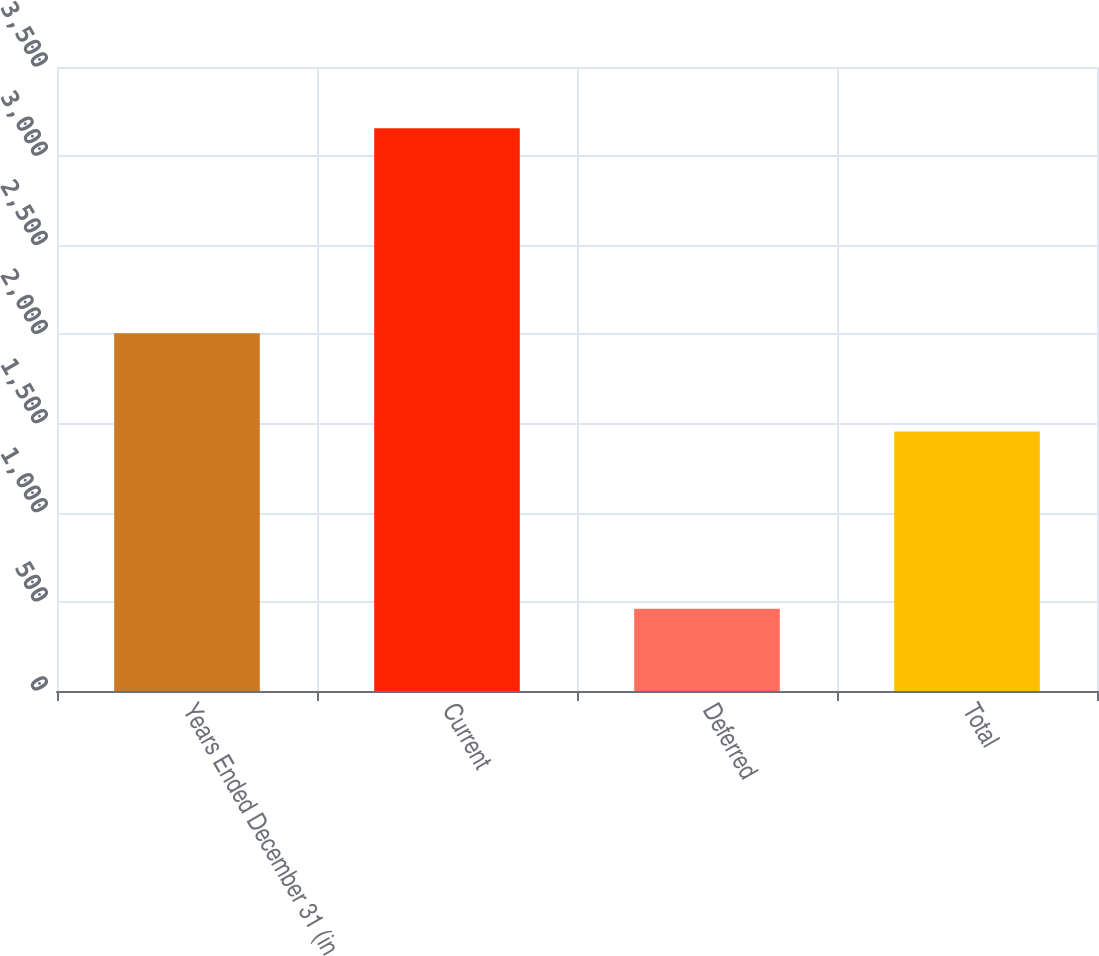Convert chart. <chart><loc_0><loc_0><loc_500><loc_500><bar_chart><fcel>Years Ended December 31 (in<fcel>Current<fcel>Deferred<fcel>Total<nl><fcel>2007<fcel>3157<fcel>461<fcel>1455<nl></chart> 